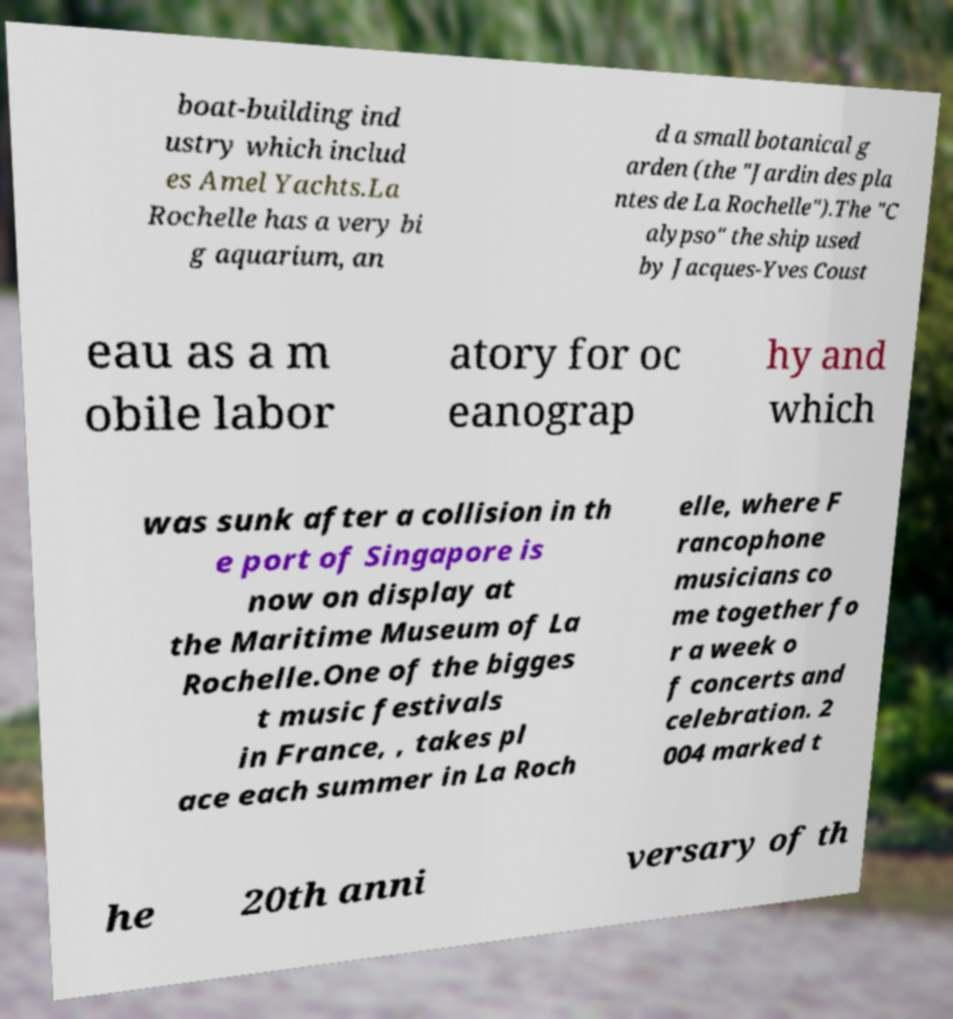What messages or text are displayed in this image? I need them in a readable, typed format. boat-building ind ustry which includ es Amel Yachts.La Rochelle has a very bi g aquarium, an d a small botanical g arden (the "Jardin des pla ntes de La Rochelle").The "C alypso" the ship used by Jacques-Yves Coust eau as a m obile labor atory for oc eanograp hy and which was sunk after a collision in th e port of Singapore is now on display at the Maritime Museum of La Rochelle.One of the bigges t music festivals in France, , takes pl ace each summer in La Roch elle, where F rancophone musicians co me together fo r a week o f concerts and celebration. 2 004 marked t he 20th anni versary of th 